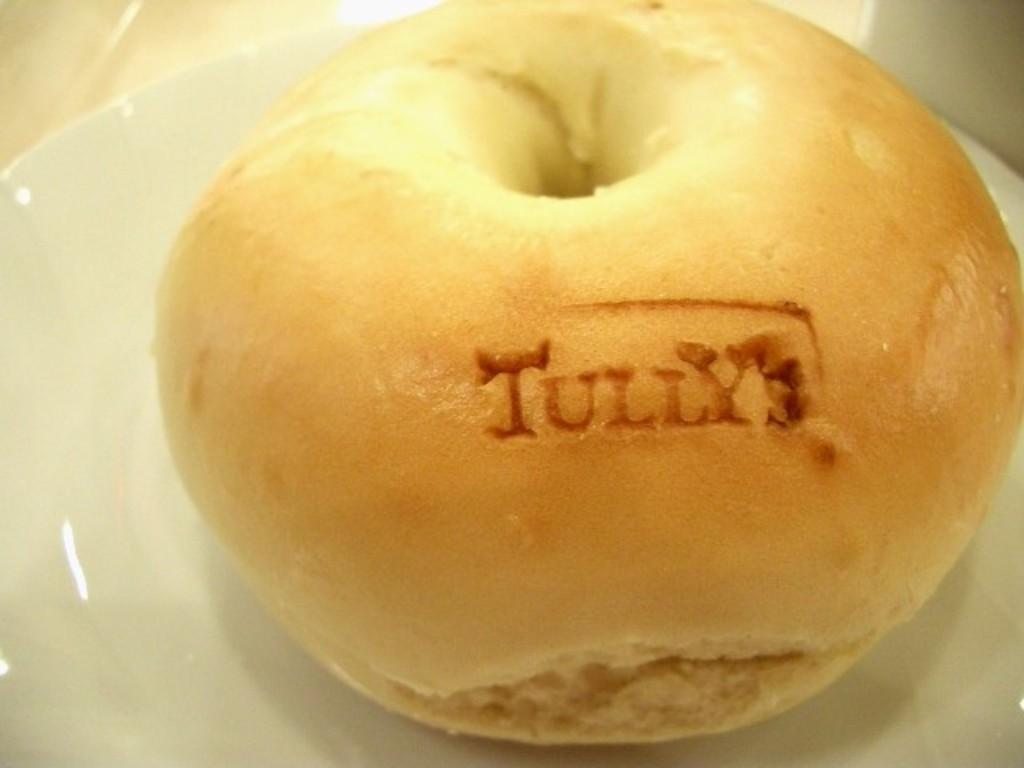Please provide a concise description of this image. This image consists of a food which is on the plate in the center. 